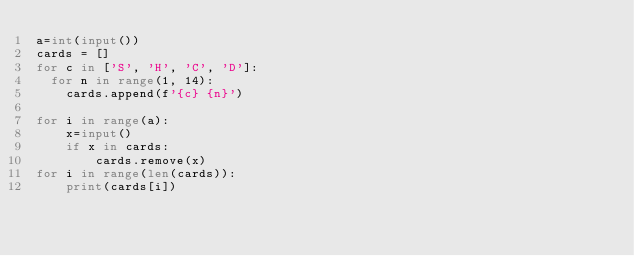Convert code to text. <code><loc_0><loc_0><loc_500><loc_500><_Python_>a=int(input())
cards = []
for c in ['S', 'H', 'C', 'D']:
  for n in range(1, 14):
    cards.append(f'{c} {n}')

for i in range(a):
    x=input()
    if x in cards:
        cards.remove(x)
for i in range(len(cards)):
    print(cards[i])
</code> 